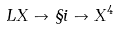<formula> <loc_0><loc_0><loc_500><loc_500>L X \to \S i \to X ^ { 4 }</formula> 